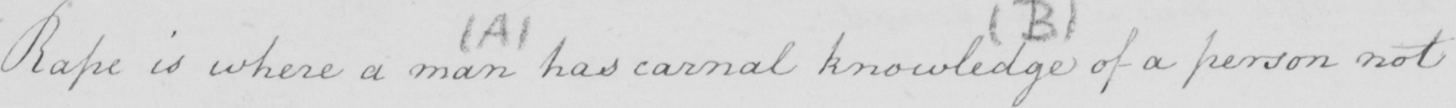Please provide the text content of this handwritten line. Rape is where a man has carnal knowledge of a person not 